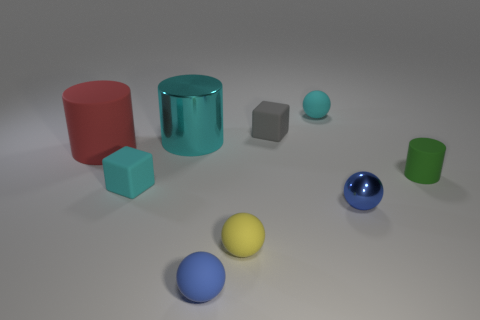Subtract all cyan balls. How many balls are left? 3 Subtract all red balls. Subtract all red cubes. How many balls are left? 4 Add 1 tiny blocks. How many objects exist? 10 Subtract all balls. How many objects are left? 5 Subtract 0 purple balls. How many objects are left? 9 Subtract all big cyan shiny cylinders. Subtract all tiny rubber balls. How many objects are left? 5 Add 2 tiny blue metallic objects. How many tiny blue metallic objects are left? 3 Add 8 tiny cyan cylinders. How many tiny cyan cylinders exist? 8 